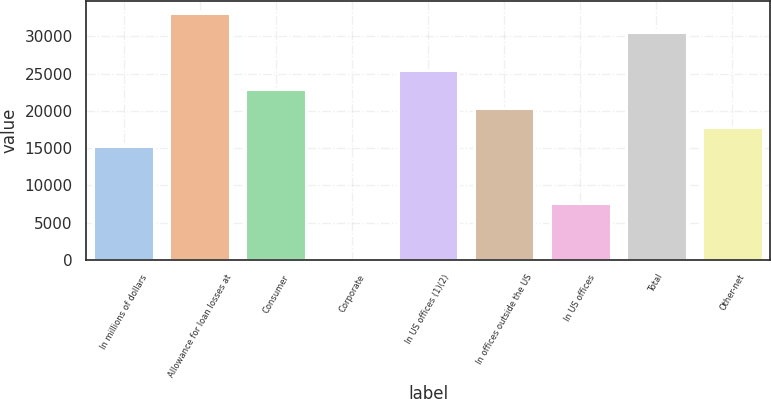Convert chart. <chart><loc_0><loc_0><loc_500><loc_500><bar_chart><fcel>In millions of dollars<fcel>Allowance for loan losses at<fcel>Consumer<fcel>Corporate<fcel>In US offices (1)(2)<fcel>In offices outside the US<fcel>In US offices<fcel>Total<fcel>Other-net<nl><fcel>15273.4<fcel>33091.2<fcel>22909.6<fcel>1<fcel>25455<fcel>20364.2<fcel>7637.2<fcel>30545.8<fcel>17818.8<nl></chart> 